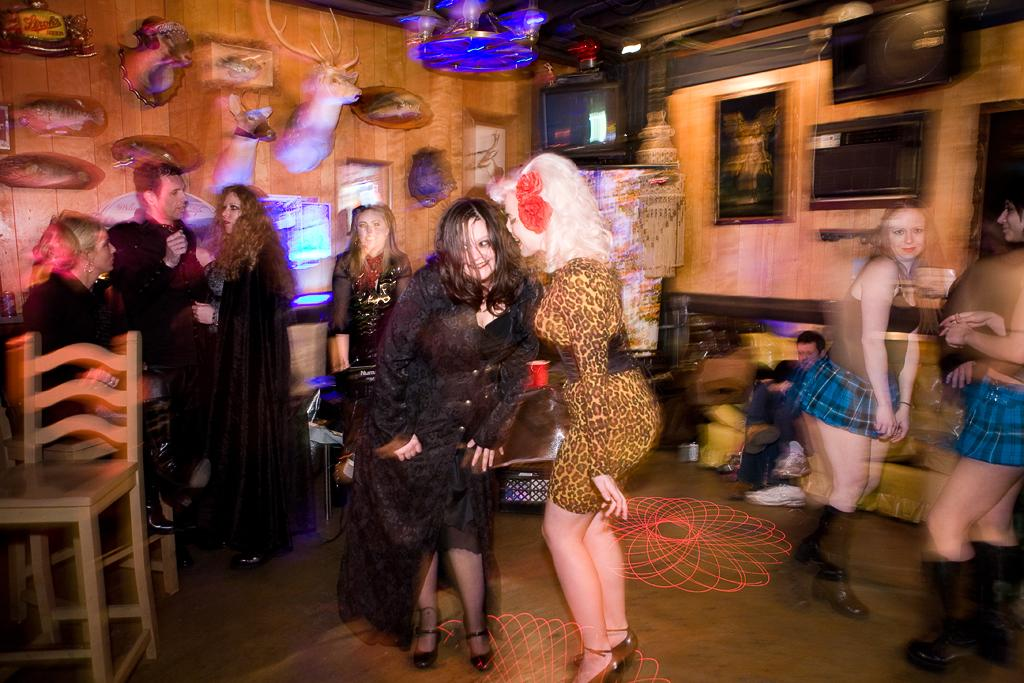How many people are in the image? There is a group of people in the image, but the exact number is not specified. What surface are the people standing on? The people are standing on the floor. What furniture is present in the image? There is a table and a chair in the image. What type of steel is used to construct the pest in the image? There is no pest present in the image, and therefore no steel construction can be observed. Can you see the moon in the image? The image does not depict the moon or any celestial bodies; it only shows a group of people, a floor, a table, and a chair. 